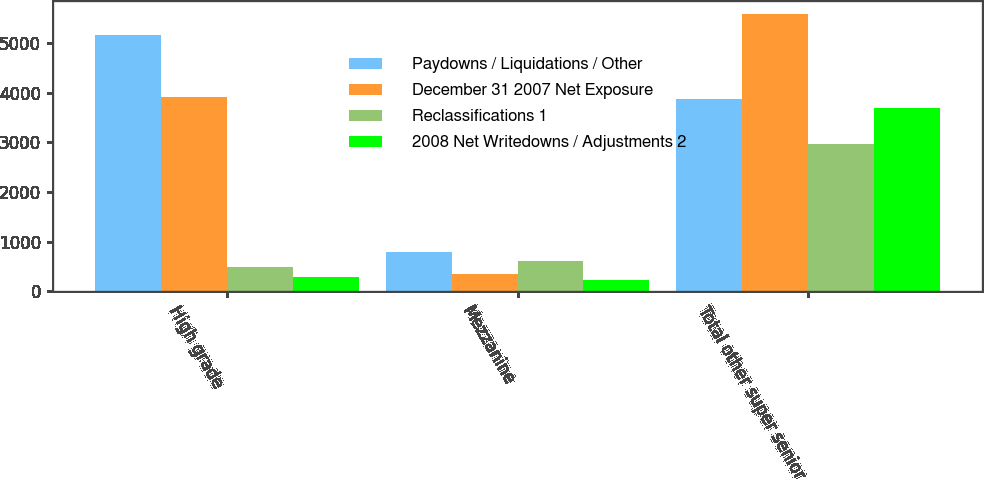Convert chart to OTSL. <chart><loc_0><loc_0><loc_500><loc_500><stacked_bar_chart><ecel><fcel>High grade<fcel>Mezzanine<fcel>Total other super senior<nl><fcel>Paydowns / Liquidations / Other<fcel>5166<fcel>795<fcel>3879<nl><fcel>December 31 2007 Net Exposure<fcel>3917<fcel>337<fcel>5572<nl><fcel>Reclassifications 1<fcel>486<fcel>606<fcel>2957<nl><fcel>2008 Net Writedowns / Adjustments 2<fcel>287<fcel>229<fcel>3690<nl></chart> 